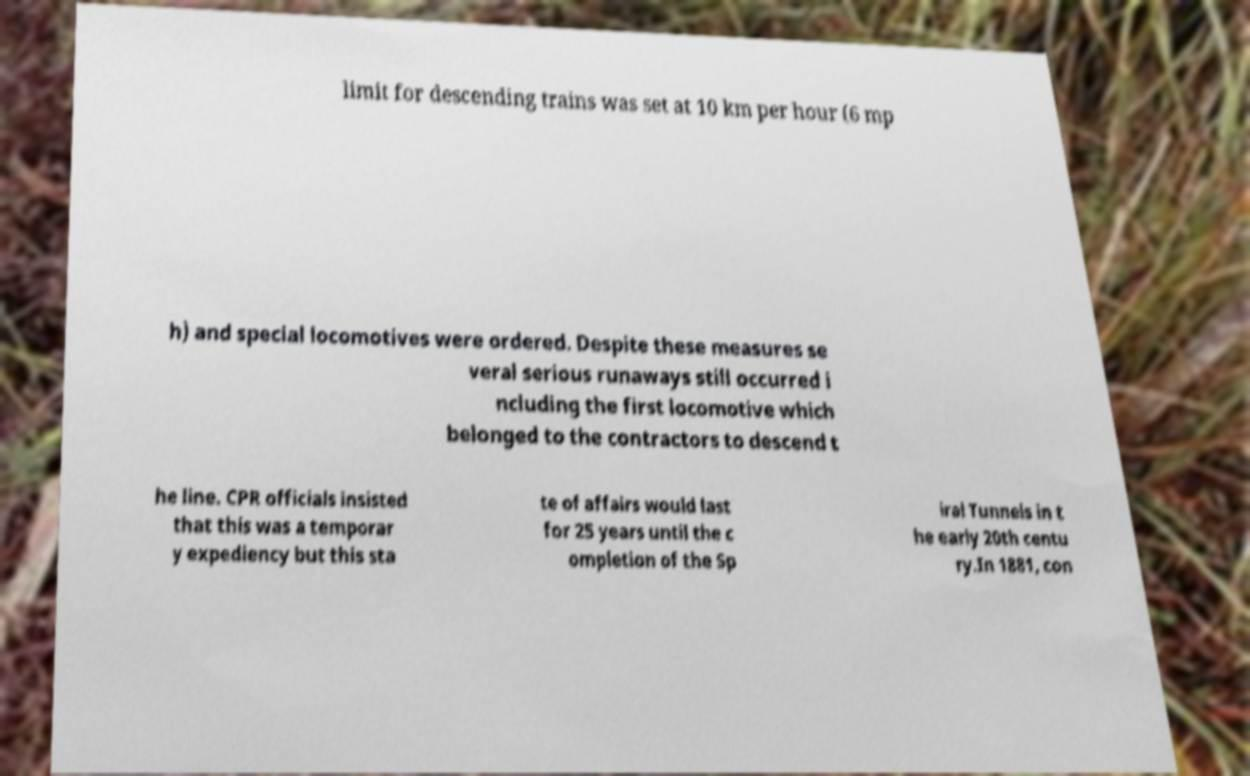I need the written content from this picture converted into text. Can you do that? limit for descending trains was set at 10 km per hour (6 mp h) and special locomotives were ordered. Despite these measures se veral serious runaways still occurred i ncluding the first locomotive which belonged to the contractors to descend t he line. CPR officials insisted that this was a temporar y expediency but this sta te of affairs would last for 25 years until the c ompletion of the Sp iral Tunnels in t he early 20th centu ry.In 1881, con 